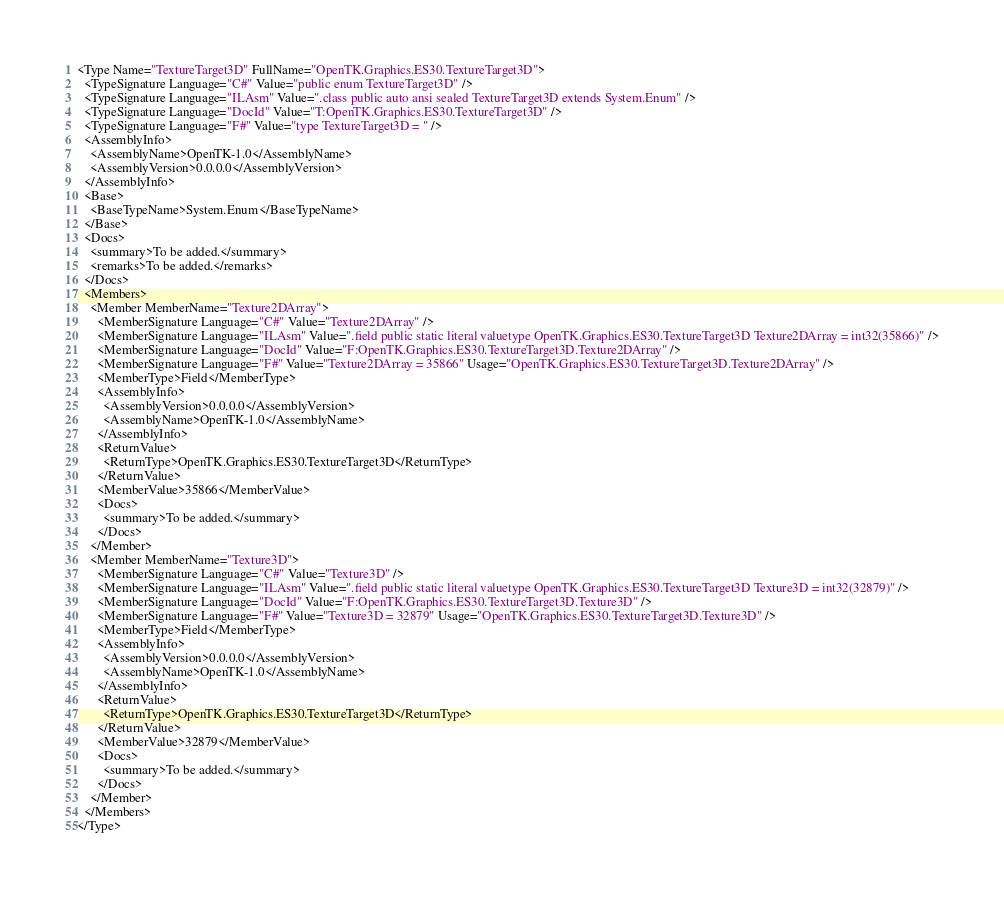<code> <loc_0><loc_0><loc_500><loc_500><_XML_><Type Name="TextureTarget3D" FullName="OpenTK.Graphics.ES30.TextureTarget3D">
  <TypeSignature Language="C#" Value="public enum TextureTarget3D" />
  <TypeSignature Language="ILAsm" Value=".class public auto ansi sealed TextureTarget3D extends System.Enum" />
  <TypeSignature Language="DocId" Value="T:OpenTK.Graphics.ES30.TextureTarget3D" />
  <TypeSignature Language="F#" Value="type TextureTarget3D = " />
  <AssemblyInfo>
    <AssemblyName>OpenTK-1.0</AssemblyName>
    <AssemblyVersion>0.0.0.0</AssemblyVersion>
  </AssemblyInfo>
  <Base>
    <BaseTypeName>System.Enum</BaseTypeName>
  </Base>
  <Docs>
    <summary>To be added.</summary>
    <remarks>To be added.</remarks>
  </Docs>
  <Members>
    <Member MemberName="Texture2DArray">
      <MemberSignature Language="C#" Value="Texture2DArray" />
      <MemberSignature Language="ILAsm" Value=".field public static literal valuetype OpenTK.Graphics.ES30.TextureTarget3D Texture2DArray = int32(35866)" />
      <MemberSignature Language="DocId" Value="F:OpenTK.Graphics.ES30.TextureTarget3D.Texture2DArray" />
      <MemberSignature Language="F#" Value="Texture2DArray = 35866" Usage="OpenTK.Graphics.ES30.TextureTarget3D.Texture2DArray" />
      <MemberType>Field</MemberType>
      <AssemblyInfo>
        <AssemblyVersion>0.0.0.0</AssemblyVersion>
        <AssemblyName>OpenTK-1.0</AssemblyName>
      </AssemblyInfo>
      <ReturnValue>
        <ReturnType>OpenTK.Graphics.ES30.TextureTarget3D</ReturnType>
      </ReturnValue>
      <MemberValue>35866</MemberValue>
      <Docs>
        <summary>To be added.</summary>
      </Docs>
    </Member>
    <Member MemberName="Texture3D">
      <MemberSignature Language="C#" Value="Texture3D" />
      <MemberSignature Language="ILAsm" Value=".field public static literal valuetype OpenTK.Graphics.ES30.TextureTarget3D Texture3D = int32(32879)" />
      <MemberSignature Language="DocId" Value="F:OpenTK.Graphics.ES30.TextureTarget3D.Texture3D" />
      <MemberSignature Language="F#" Value="Texture3D = 32879" Usage="OpenTK.Graphics.ES30.TextureTarget3D.Texture3D" />
      <MemberType>Field</MemberType>
      <AssemblyInfo>
        <AssemblyVersion>0.0.0.0</AssemblyVersion>
        <AssemblyName>OpenTK-1.0</AssemblyName>
      </AssemblyInfo>
      <ReturnValue>
        <ReturnType>OpenTK.Graphics.ES30.TextureTarget3D</ReturnType>
      </ReturnValue>
      <MemberValue>32879</MemberValue>
      <Docs>
        <summary>To be added.</summary>
      </Docs>
    </Member>
  </Members>
</Type>
</code> 